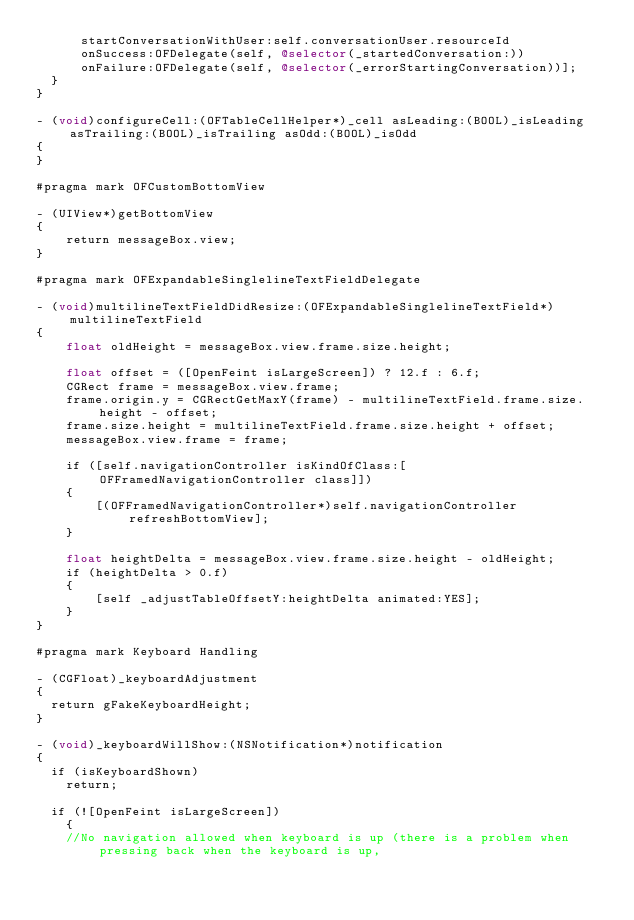<code> <loc_0><loc_0><loc_500><loc_500><_ObjectiveC_>			startConversationWithUser:self.conversationUser.resourceId 
			onSuccess:OFDelegate(self, @selector(_startedConversation:)) 
			onFailure:OFDelegate(self, @selector(_errorStartingConversation))];
	}
}

- (void)configureCell:(OFTableCellHelper*)_cell asLeading:(BOOL)_isLeading asTrailing:(BOOL)_isTrailing asOdd:(BOOL)_isOdd
{
}

#pragma mark OFCustomBottomView

- (UIView*)getBottomView
{    
    return messageBox.view;
}

#pragma mark OFExpandableSinglelineTextFieldDelegate

- (void)multilineTextFieldDidResize:(OFExpandableSinglelineTextField*)multilineTextField
{
    float oldHeight = messageBox.view.frame.size.height;

    float offset = ([OpenFeint isLargeScreen]) ? 12.f : 6.f;
    CGRect frame = messageBox.view.frame;
    frame.origin.y = CGRectGetMaxY(frame) - multilineTextField.frame.size.height - offset;
    frame.size.height = multilineTextField.frame.size.height + offset;
    messageBox.view.frame = frame;
    
    if ([self.navigationController isKindOfClass:[OFFramedNavigationController class]])
    {
        [(OFFramedNavigationController*)self.navigationController refreshBottomView];
    }

    float heightDelta = messageBox.view.frame.size.height - oldHeight;
    if (heightDelta > 0.f)
    {
        [self _adjustTableOffsetY:heightDelta animated:YES];
    }
}

#pragma mark Keyboard Handling

- (CGFloat)_keyboardAdjustment
{
	return gFakeKeyboardHeight;
}

- (void)_keyboardWillShow:(NSNotification*)notification
{
	if (isKeyboardShown)
		return;

	if (![OpenFeint isLargeScreen])
    {
		//No navigation allowed when keyboard is up (there is a problem when pressing back when the keyboard is up,</code> 